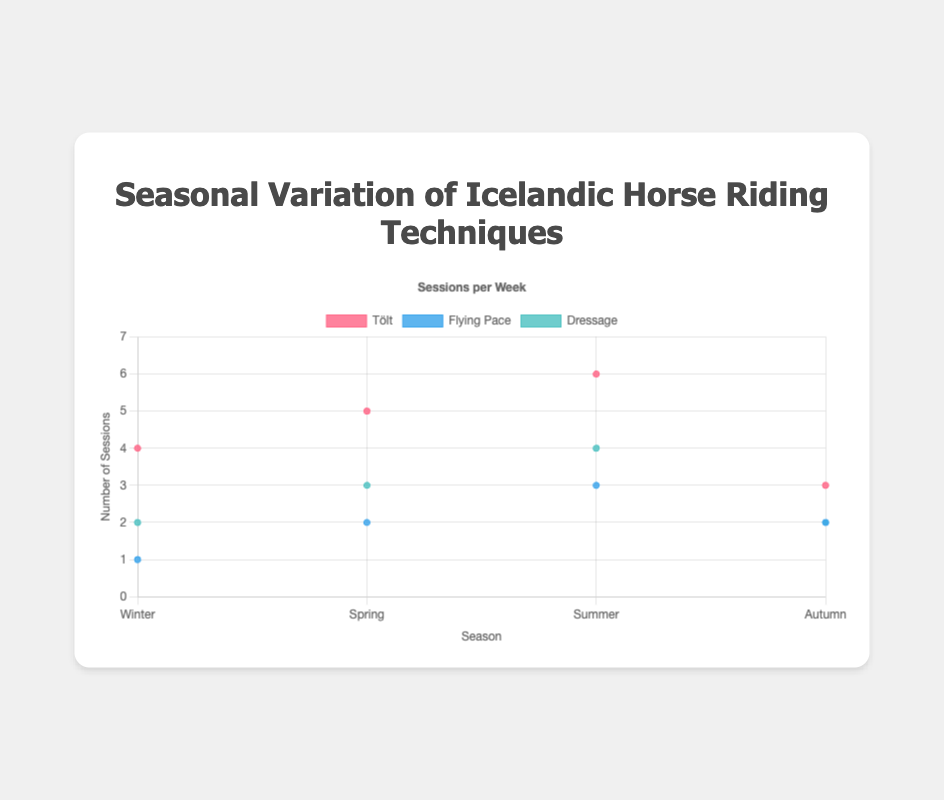What's the title of the figure? The title is prominently displayed at the top of the figure.
Answer: Seasonal Variation of Icelandic Horse Riding Techniques What is the x-axis representing? The x-axis is labeled, showing divisions based on seasons.
Answer: Season What is the y-axis representing? The y-axis is labeled and shows numerical values indicating frequency.
Answer: Number of Sessions Which riding technique has the most sessions in Summer? For Summer, the y-values for each riding technique are compared; Tölt has the highest with a value of 6.
Answer: Tölt How many sessions of Dressage are practiced in Winter and Autumn combined? Sum the sessions from Winter (2) and Autumn (2) for Dressage.
Answer: 4 What is the difference in Tölt sessions between Winter and Spring? Subtract Winter sessions for Tölt (4) from Spring sessions (5).
Answer: 1 Which season has the least sessions overall for Tölt? By comparing y-values of Tölt across seasons, Autumn has the least sessions (3).
Answer: Autumn How does the number of Flying Pace sessions change from Spring to Summer? Observe the data points for Flying Pace in Spring (2) and Summer (3); it increases by 1.
Answer: Increases by 1 What's the average number of Dressage sessions across all seasons? Add Dressage sessions for all seasons (2+3+4+2 = 11) and divide by 4.
Answer: 2.75 Which riding technique shows an overall increase in sessions from Winter to Summer? Tölt (4 to 6), Flying Pace (1 to 3), and Dressage (2 to 4) all increase; compare for consistent increase from Winter to Summer.
Answer: All three techniques (Tölt, Flying Pace, Dressage) 